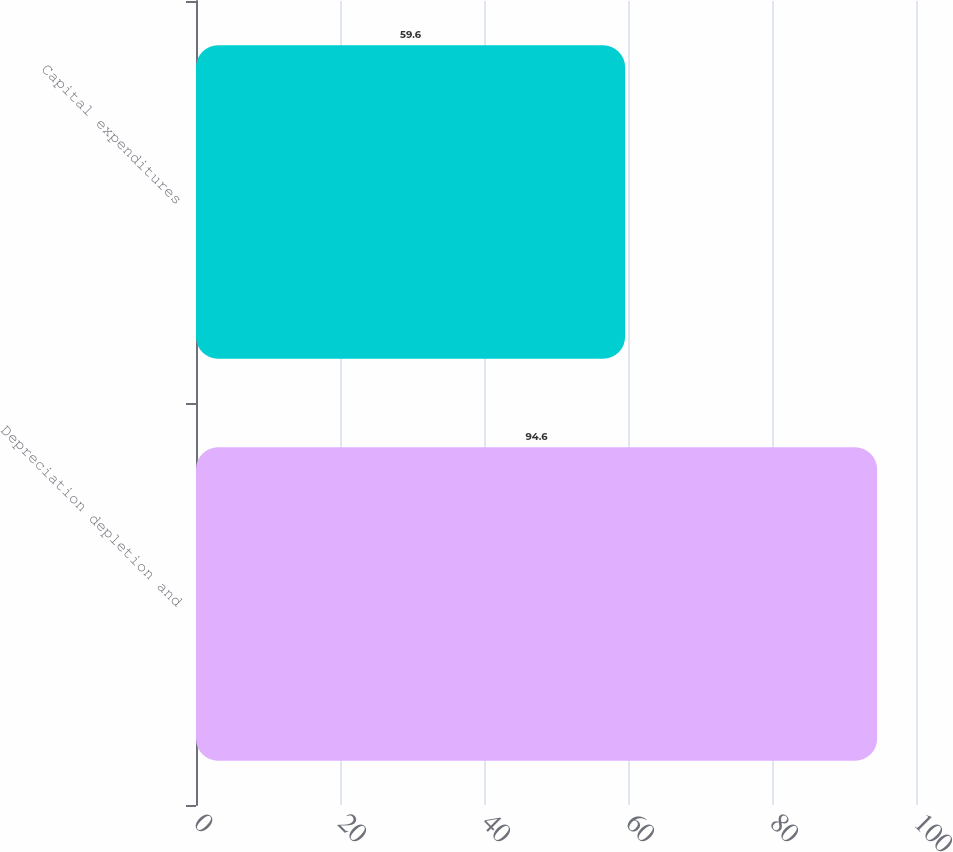Convert chart to OTSL. <chart><loc_0><loc_0><loc_500><loc_500><bar_chart><fcel>Depreciation depletion and<fcel>Capital expenditures<nl><fcel>94.6<fcel>59.6<nl></chart> 